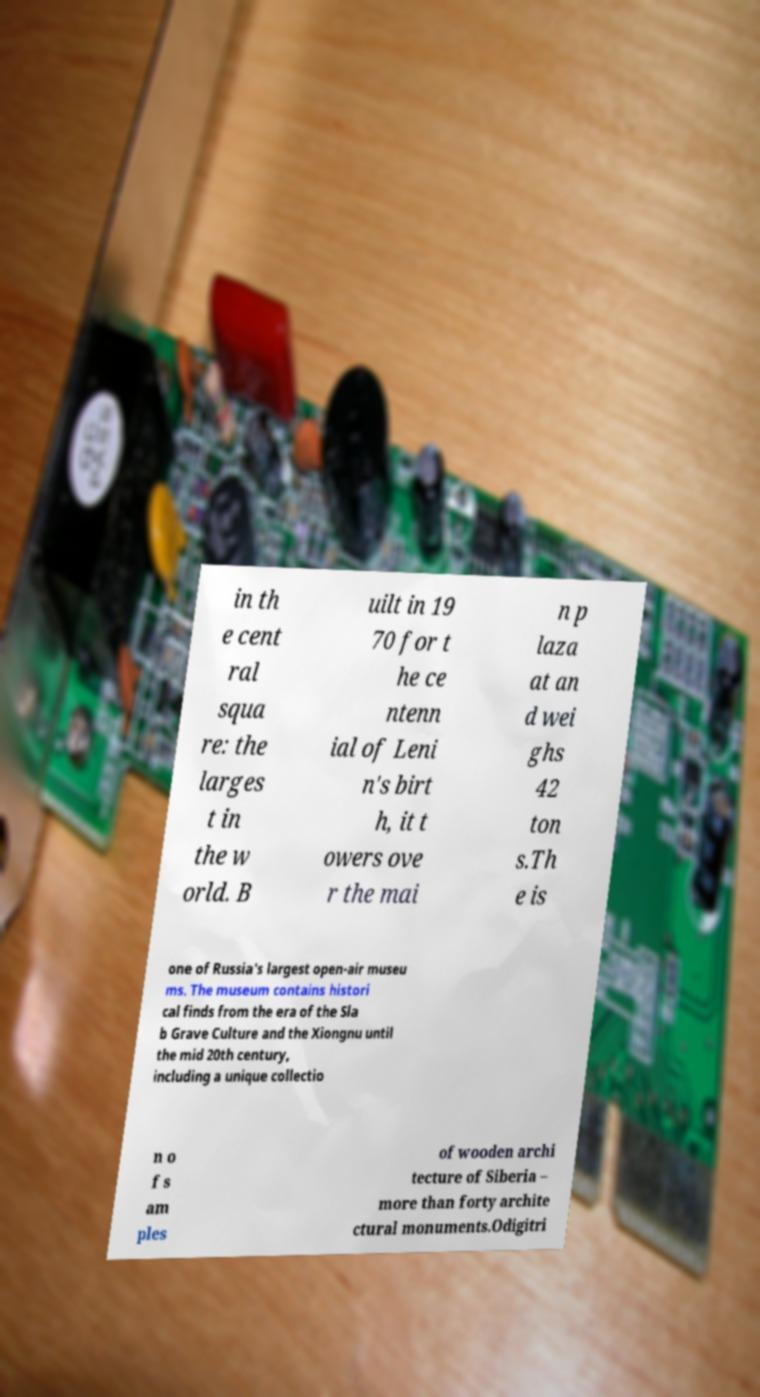What messages or text are displayed in this image? I need them in a readable, typed format. in th e cent ral squa re: the larges t in the w orld. B uilt in 19 70 for t he ce ntenn ial of Leni n's birt h, it t owers ove r the mai n p laza at an d wei ghs 42 ton s.Th e is one of Russia's largest open-air museu ms. The museum contains histori cal finds from the era of the Sla b Grave Culture and the Xiongnu until the mid 20th century, including a unique collectio n o f s am ples of wooden archi tecture of Siberia – more than forty archite ctural monuments.Odigitri 